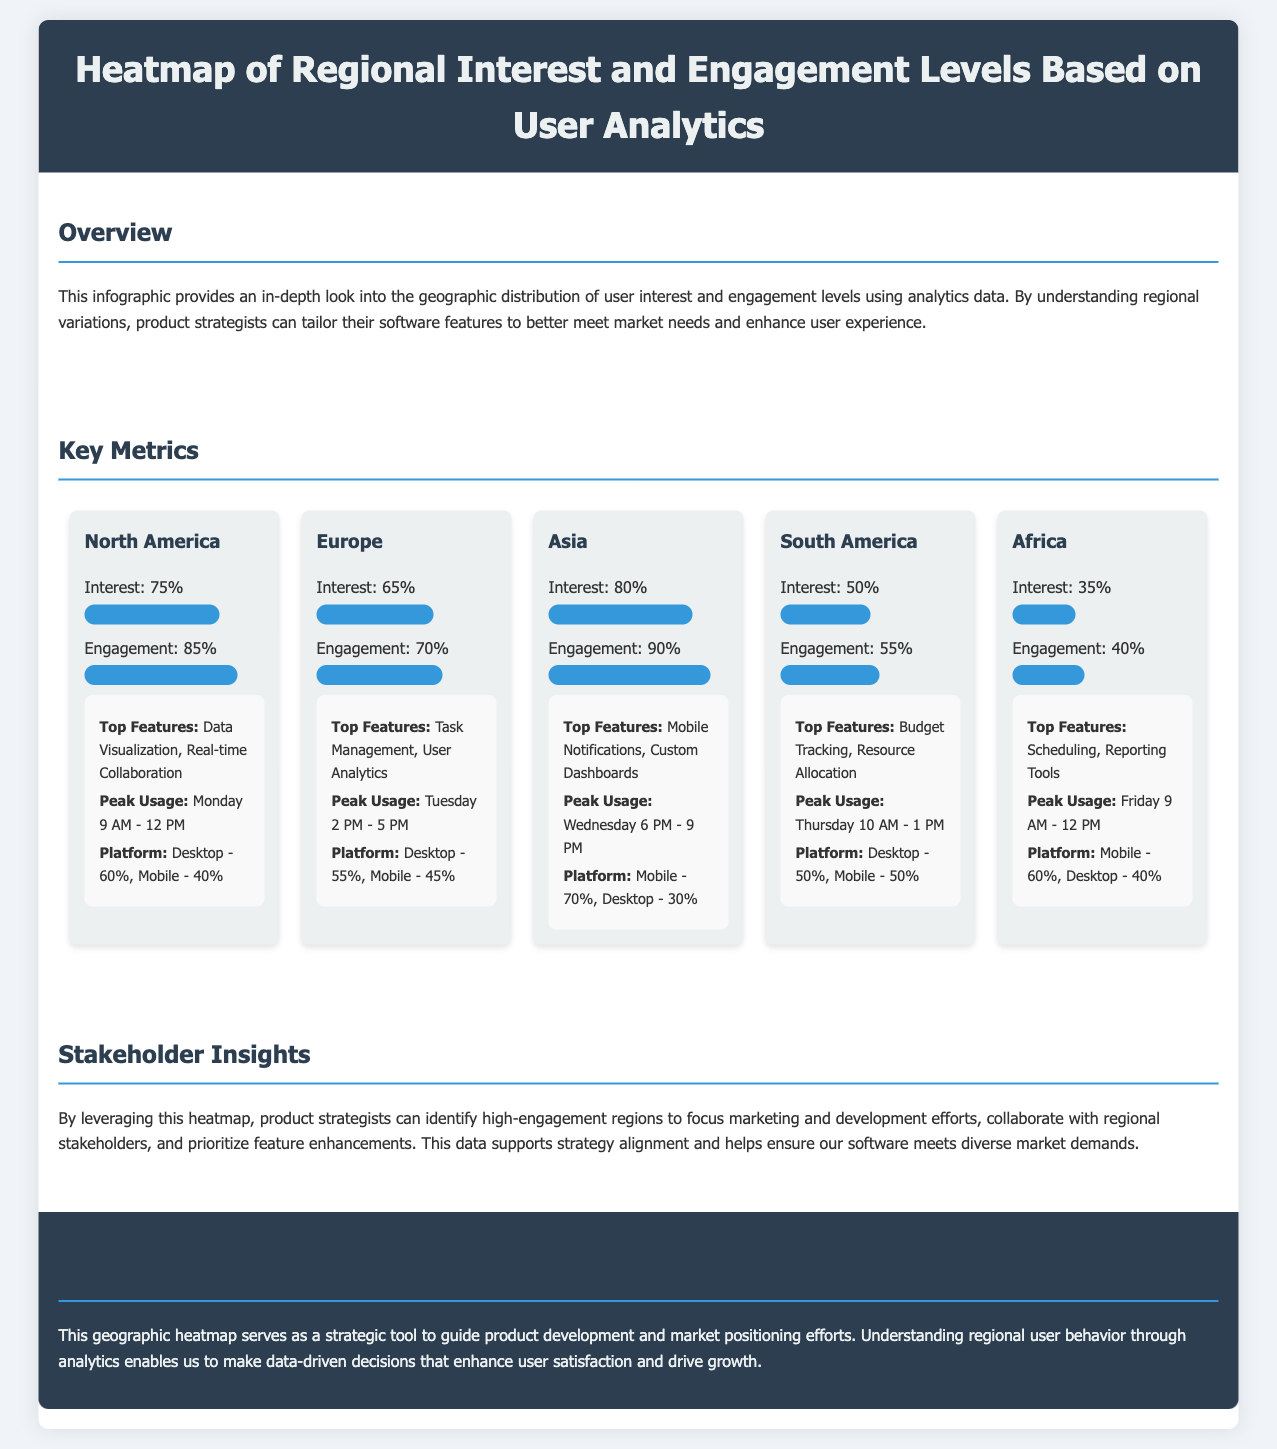What is the interest level in North America? The interest level in North America is stated directly in the document.
Answer: 75% What is the top feature for Asia? The top feature for Asia is mentioned in the analytics section related to that region.
Answer: Mobile Notifications What is the engagement level in Africa? The engagement level in Africa can be found in the metrics section of the document.
Answer: 40% When is the peak usage time for South America? The peak usage time for South America is clearly outlined in the analytics section.
Answer: Thursday 10 AM - 1 PM Which region has the highest engagement level? By comparing the engagement levels of all regions mentioned, we can identify the one with the highest score.
Answer: Asia What percentage of users in Europe engage through desktop? The platform distribution for Europe is provided in the analytics section.
Answer: 55% What is the total interest level for all regions combined? The total interest level requires adding up the individual interest levels from all regions.
Answer: 405% What are the peak usage times in North America? The peak usage time for North America is stated in the analytics for that region.
Answer: Monday 9 AM - 12 PM What color represents the interest bar for each region? The color of the interest bar is consistent and specified in the styling of the heatmap.
Answer: #3498db 